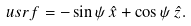<formula> <loc_0><loc_0><loc_500><loc_500>\ u s r f = - \sin \psi \, \hat { x } + \cos \psi \, \hat { z } .</formula> 